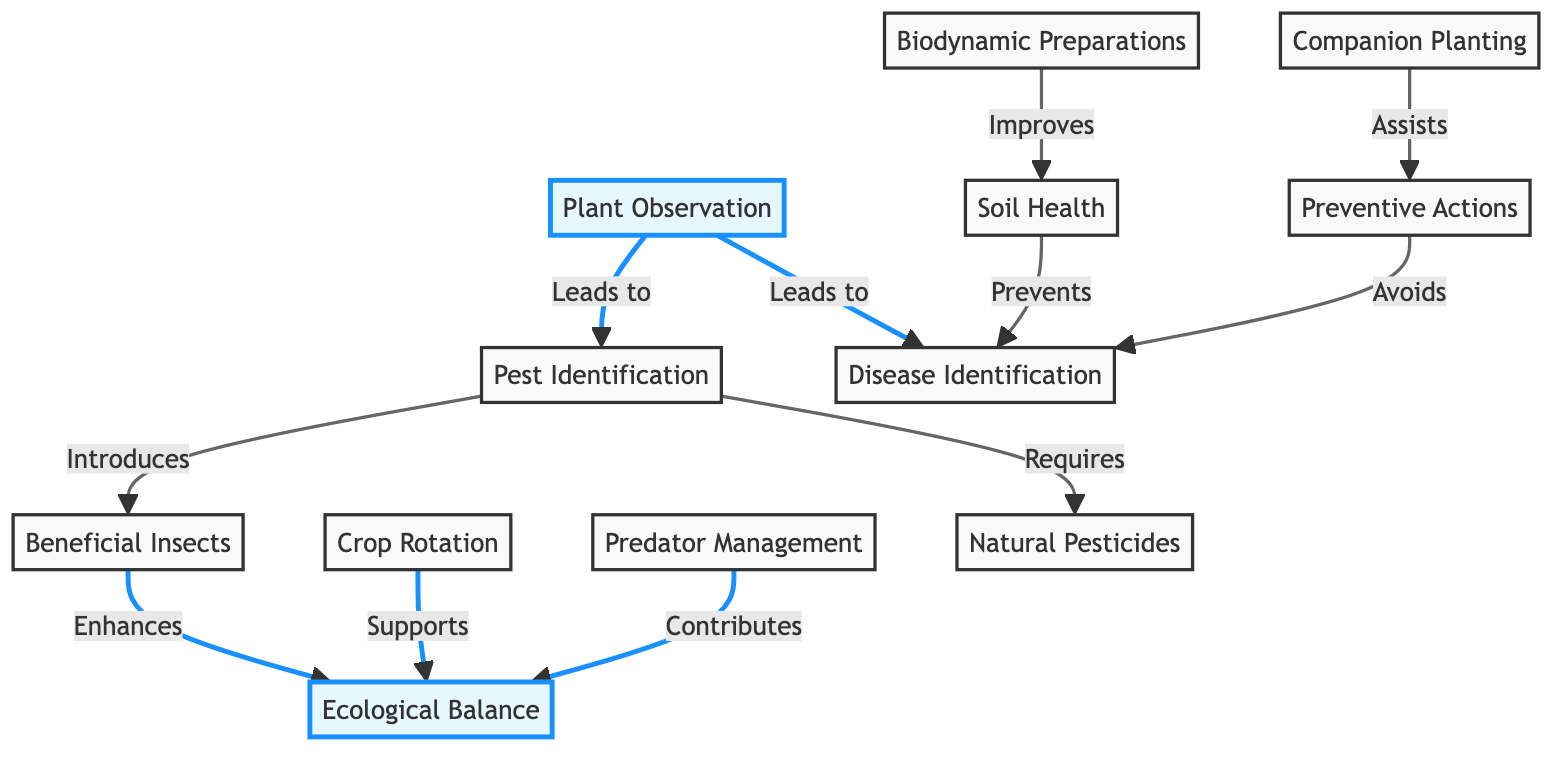What is the first step in pest management according to the diagram? The diagram indicates that "Plant Observation" is the first step as it leads to both "Pest Identification" and "Disease Identification".
Answer: Plant Observation How many nodes are related to disease management in the diagram? The relevant nodes for disease management are "Disease Identification", "Soil Health", and "Preventive Actions". Therefore, there are three nodes.
Answer: 3 What does "Beneficial Insects" enhance in the ecological system? According to the diagram, "Beneficial Insects" enhances "Ecological Balance".
Answer: Ecological Balance Which two methods are required after "Pest Identification"? The diagram shows that after "Pest Identification", both "Beneficial Insects" and "Natural Pesticides" are introduced and required respectively.
Answer: Beneficial Insects, Natural Pesticides What action is assisted by "Companion Planting"? The diagram indicates that "Companion Planting" assists "Preventive Actions".
Answer: Preventive Actions What prevents disease according to the diagram? The diagram states that "Soil Health" prevents "Disease Identification".
Answer: Soil Health How does "Predator Management" impact ecological balance? The diagram shows that "Predator Management" contributes to "Ecological Balance", indicating a positive impact.
Answer: Contributes What supports ecological balance in the system? Based on the relationships in the diagram, "Crop Rotation" supports "Ecological Balance".
Answer: Crop Rotation Which action avoids disease in the management system? The diagram outlines that "Preventive Actions" avoids "Disease Identification".
Answer: Preventive Actions 